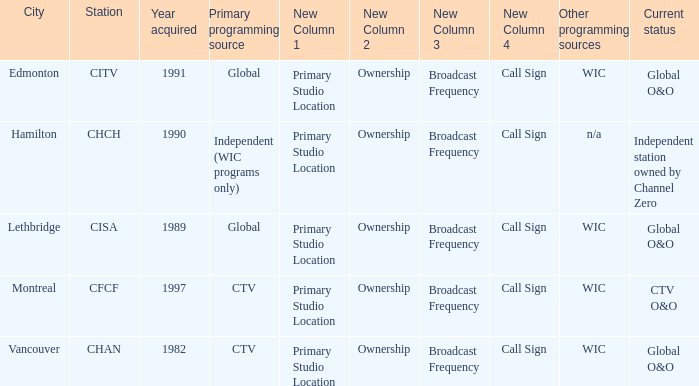How many channels were added in 1997? 1.0. 